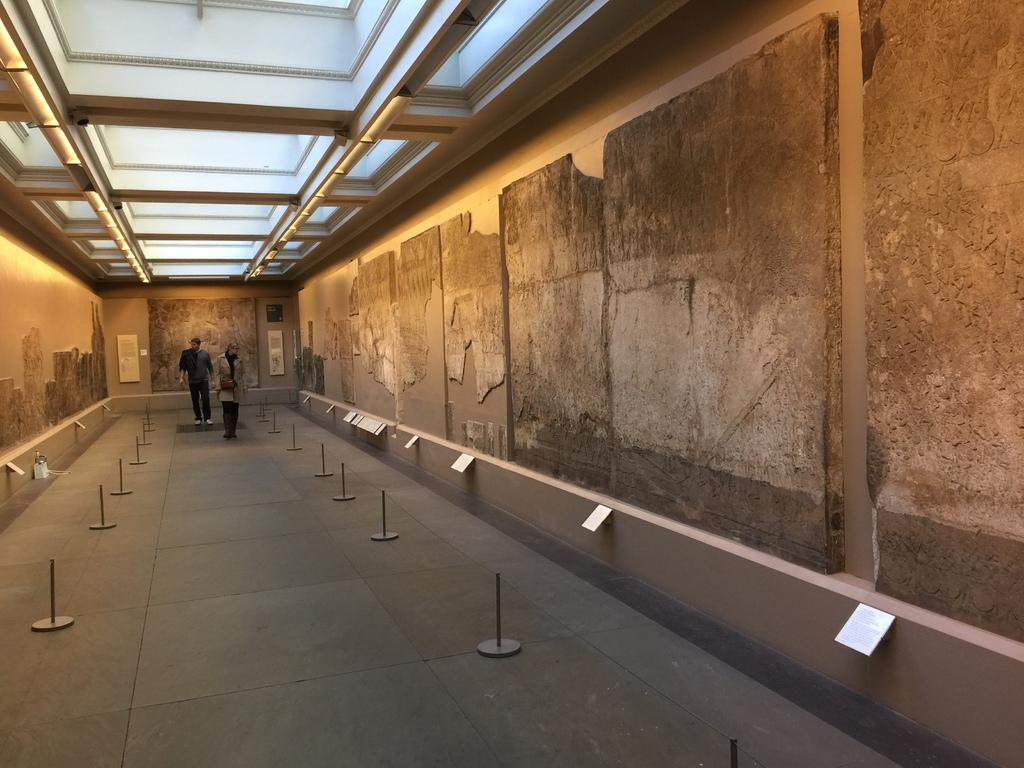What are the two people in the image doing? The two people in the image are walking. What can be seen on the wall in the image? There are objects placed on the wall and boards attached to the wall. What type of eggnog is being served in the image? There is no eggnog present in the image. 